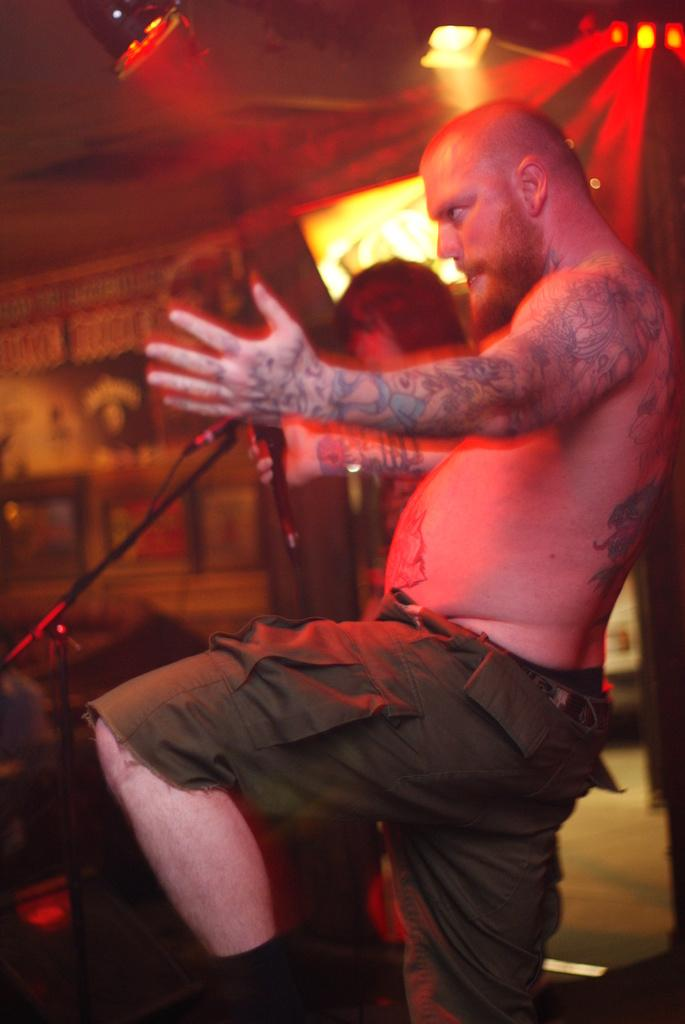What is the main subject of the image? There is a man standing in the image. What object is present near the man? There is a microphone with a stand in the image. Can you describe the background of the image? The background of the image is blurry. Are there any other people visible in the image? Yes, there is a person visible in the background of the image. What else can be seen in the background of the image? There are lights visible in the background of the image. What type of corn is being harvested in the image? There is no corn present in the image; it features a man standing with a microphone and a blurry background. How many fangs can be seen on the man in the image? There are no fangs visible on the man in the image. 